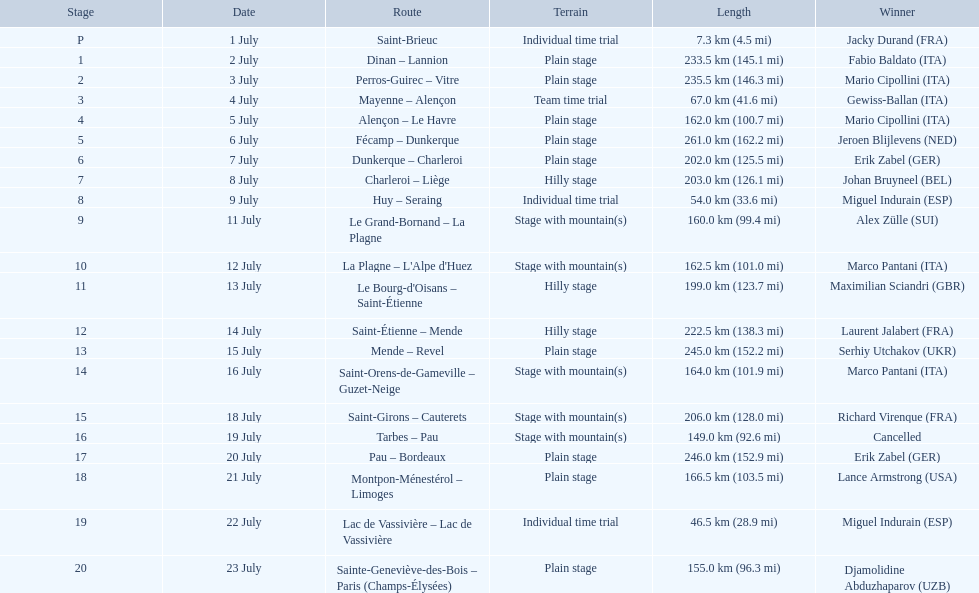Which courses were no less than 100 km? Dinan - Lannion, Perros-Guirec - Vitre, Alençon - Le Havre, Fécamp - Dunkerque, Dunkerque - Charleroi, Charleroi - Liège, Le Grand-Bornand - La Plagne, La Plagne - L'Alpe d'Huez, Le Bourg-d'Oisans - Saint-Étienne, Saint-Étienne - Mende, Mende - Revel, Saint-Orens-de-Gameville - Guzet-Neige, Saint-Girons - Cauterets, Tarbes - Pau, Pau - Bordeaux, Montpon-Ménestérol - Limoges, Sainte-Geneviève-des-Bois - Paris (Champs-Élysées). 